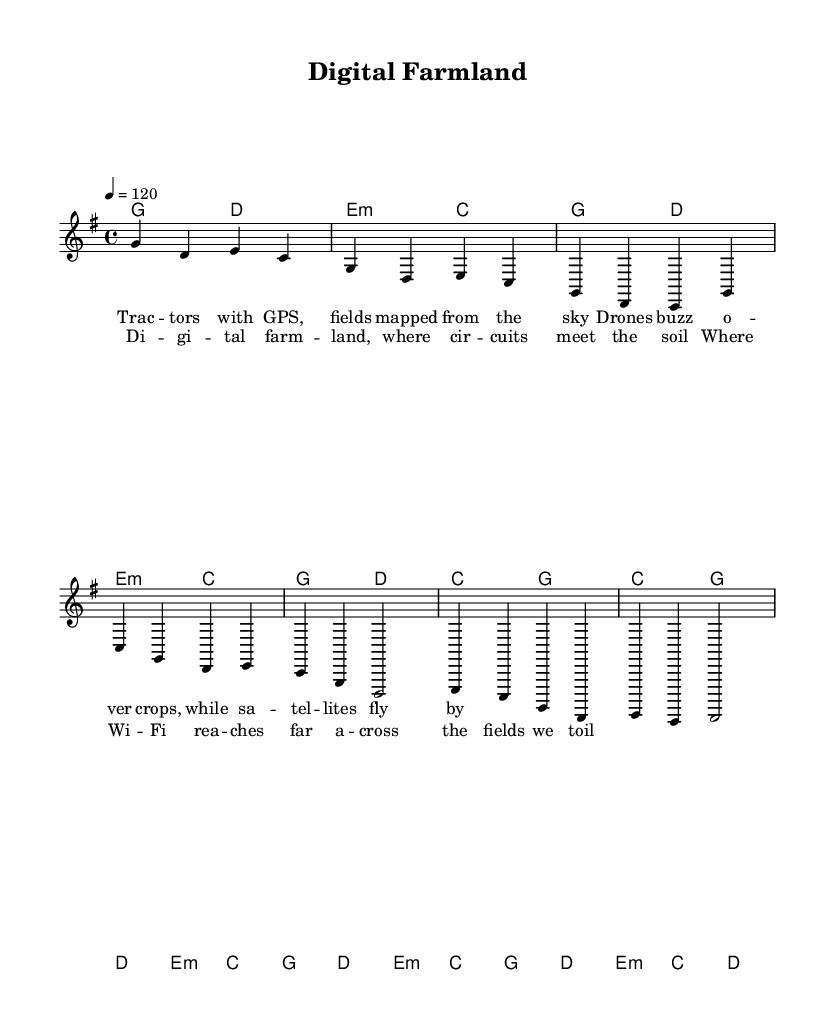What is the key signature of this music? The key signature is G major, which has one sharp (F#). You can tell because the piece starts with the key indication in the global declaration ("\key g \major").
Answer: G major What is the time signature of this music? The time signature is 4/4, indicating that there are four beats in each measure. This information is also indicated in the global part of the score where the time signature is declared ("\time 4/4").
Answer: 4/4 What is the tempo marking of the piece? The tempo marking is 120 beats per minute, as indicated by "4 = 120" in the global declaration. This indicates how fast the piece should be played.
Answer: 120 How many measures are in the chorus? The chorus consists of four measures, as can be seen where it is laid out with four `c4`, `g`, `d`, and `e` notes. Each measure counts as one, making a total of four.
Answer: 4 What is the main theme of the lyrics? The main theme revolves around the fusion of technology and agriculture, highlighting elements like GPS tractors and Wi-Fi in rural landscapes. The lyrics specifically mention "Digital farmland" and technology's role in farming.
Answer: Technology in agriculture What is the chord progression for the verse? The chord progression in the verse consists of two repeating phrases: g d, e:m, c, and g d, c, g. These are indicated in the harmonies section directly under the verse lyrics, providing a pattern for accompaniment.
Answer: g d e:m c g d c g What makes this song identify as Country Rock? The song identifies as Country Rock due to its blend of traditional country themes, such as rural life and farming, with modern technological elements like circuits and digital fields. The lyrics reflect these combined themes, which is a hallmark of the genre.
Answer: Rural life with technology 